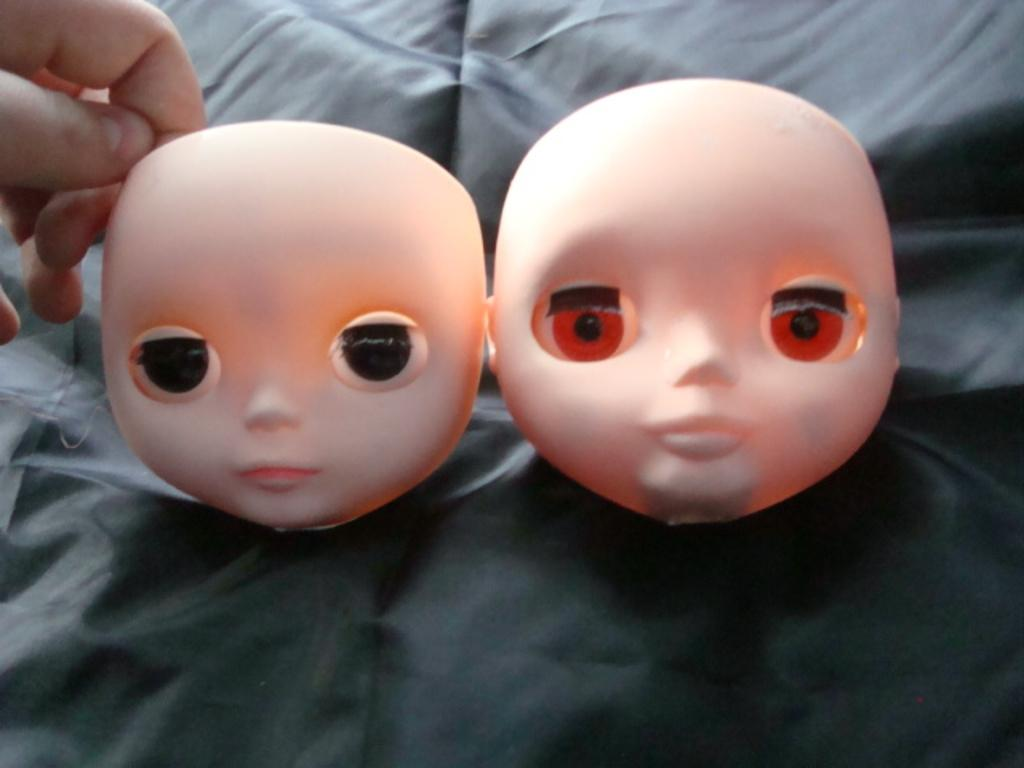What type of objects are in the image? There are dolls in the image. What is the dolls resting on? The dolls are on a black object. Can you identify any human body parts in the image? Yes, there is a hand of a person visible in the top left side of the image. What type of chin can be seen in the image? There is no chin visible in the image. Can you describe the coastline in the image? There is no coastline present in the image. 